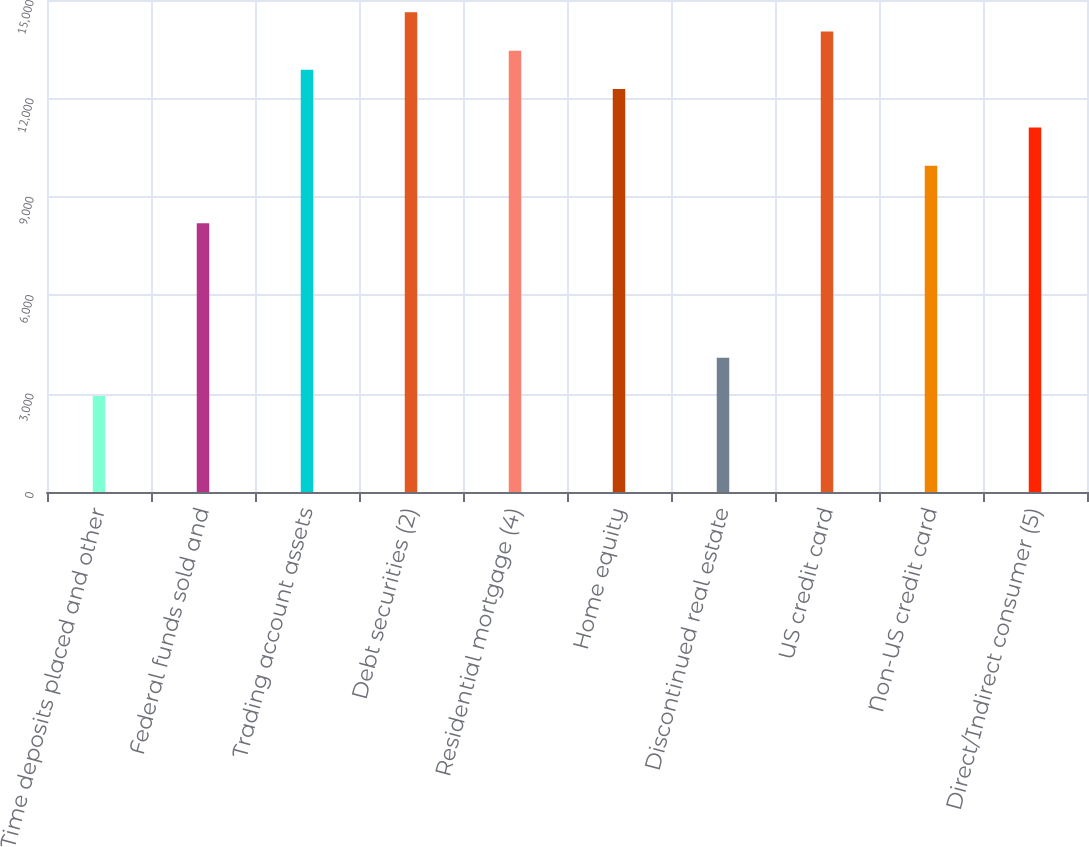<chart> <loc_0><loc_0><loc_500><loc_500><bar_chart><fcel>Time deposits placed and other<fcel>Federal funds sold and<fcel>Trading account assets<fcel>Debt securities (2)<fcel>Residential mortgage (4)<fcel>Home equity<fcel>Discontinued real estate<fcel>US credit card<fcel>Non-US credit card<fcel>Direct/Indirect consumer (5)<nl><fcel>2926.5<fcel>8190.6<fcel>12869.8<fcel>14624.5<fcel>13454.7<fcel>12284.9<fcel>4096.3<fcel>14039.6<fcel>9945.3<fcel>11115.1<nl></chart> 